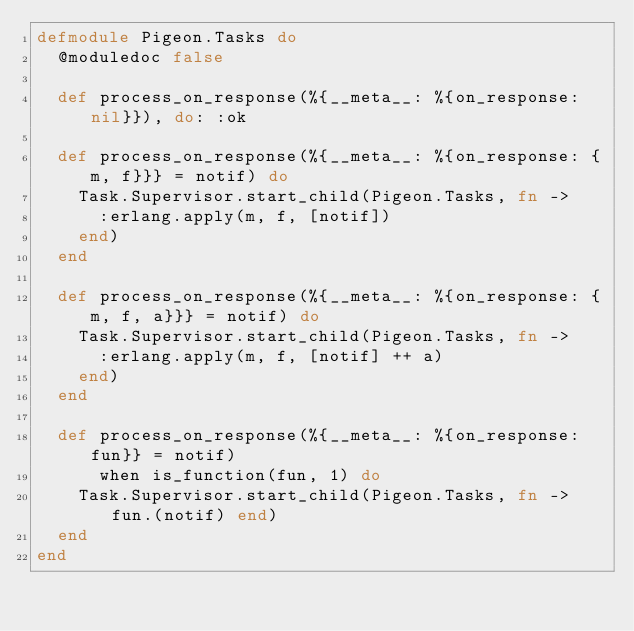Convert code to text. <code><loc_0><loc_0><loc_500><loc_500><_Elixir_>defmodule Pigeon.Tasks do
  @moduledoc false

  def process_on_response(%{__meta__: %{on_response: nil}}), do: :ok

  def process_on_response(%{__meta__: %{on_response: {m, f}}} = notif) do
    Task.Supervisor.start_child(Pigeon.Tasks, fn ->
      :erlang.apply(m, f, [notif])
    end)
  end

  def process_on_response(%{__meta__: %{on_response: {m, f, a}}} = notif) do
    Task.Supervisor.start_child(Pigeon.Tasks, fn ->
      :erlang.apply(m, f, [notif] ++ a)
    end)
  end

  def process_on_response(%{__meta__: %{on_response: fun}} = notif)
      when is_function(fun, 1) do
    Task.Supervisor.start_child(Pigeon.Tasks, fn -> fun.(notif) end)
  end
end
</code> 